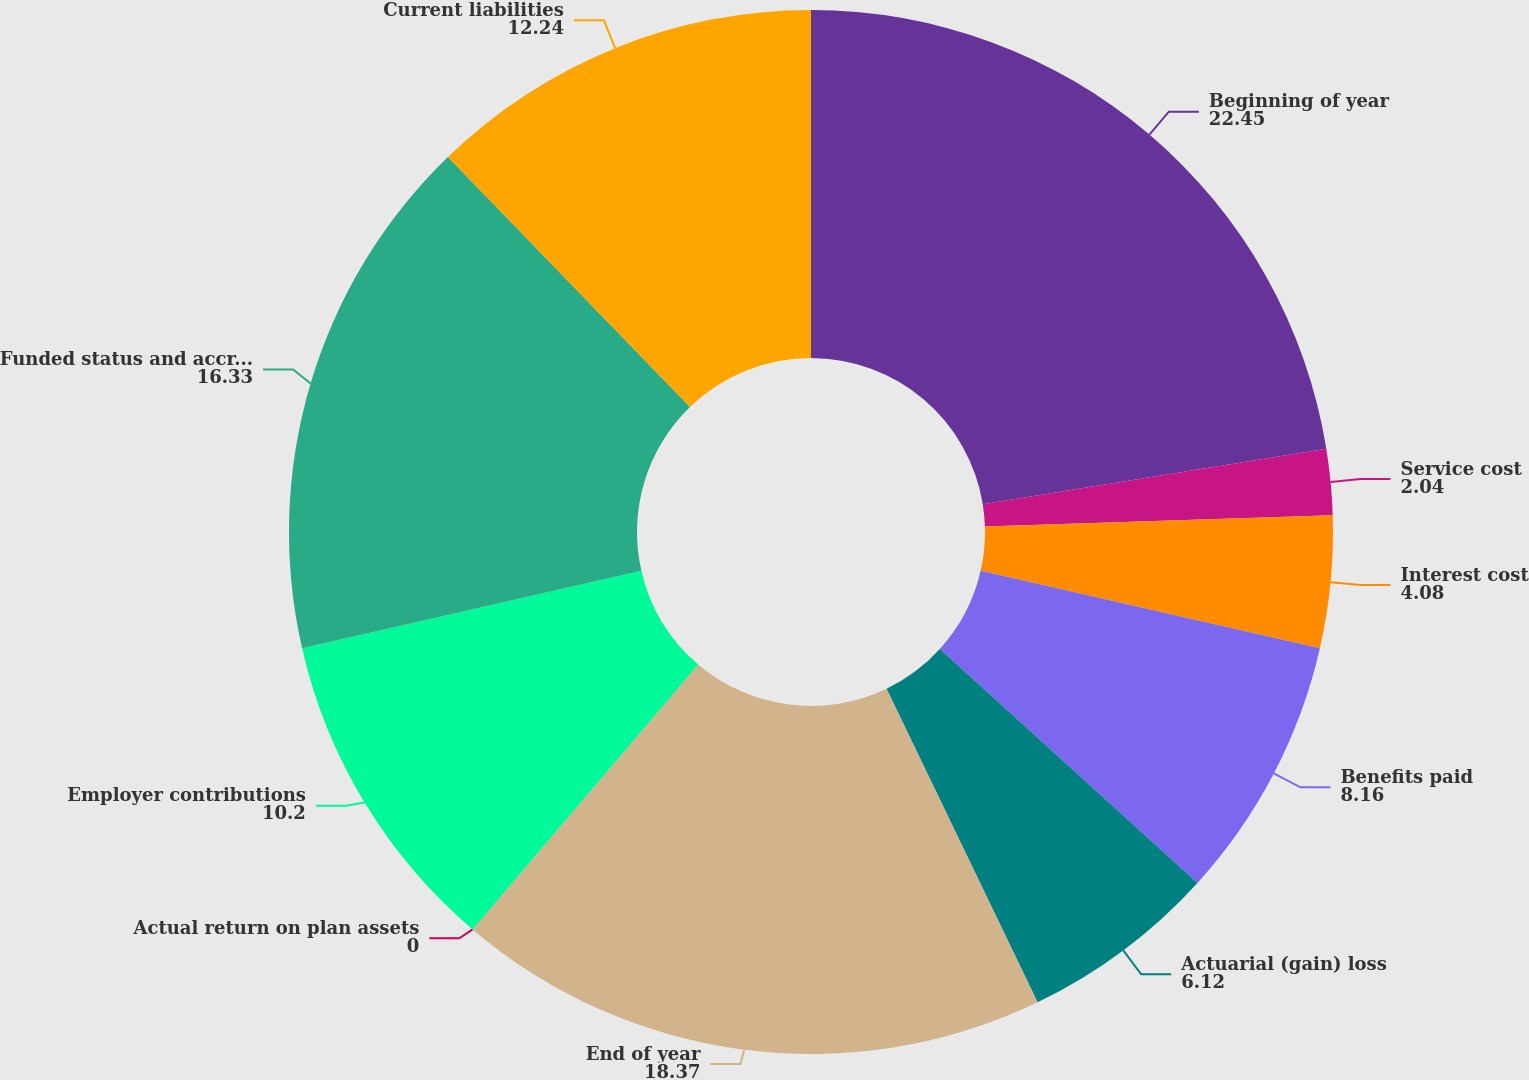<chart> <loc_0><loc_0><loc_500><loc_500><pie_chart><fcel>Beginning of year<fcel>Service cost<fcel>Interest cost<fcel>Benefits paid<fcel>Actuarial (gain) loss<fcel>End of year<fcel>Actual return on plan assets<fcel>Employer contributions<fcel>Funded status and accrued<fcel>Current liabilities<nl><fcel>22.45%<fcel>2.04%<fcel>4.08%<fcel>8.16%<fcel>6.12%<fcel>18.37%<fcel>0.0%<fcel>10.2%<fcel>16.33%<fcel>12.24%<nl></chart> 